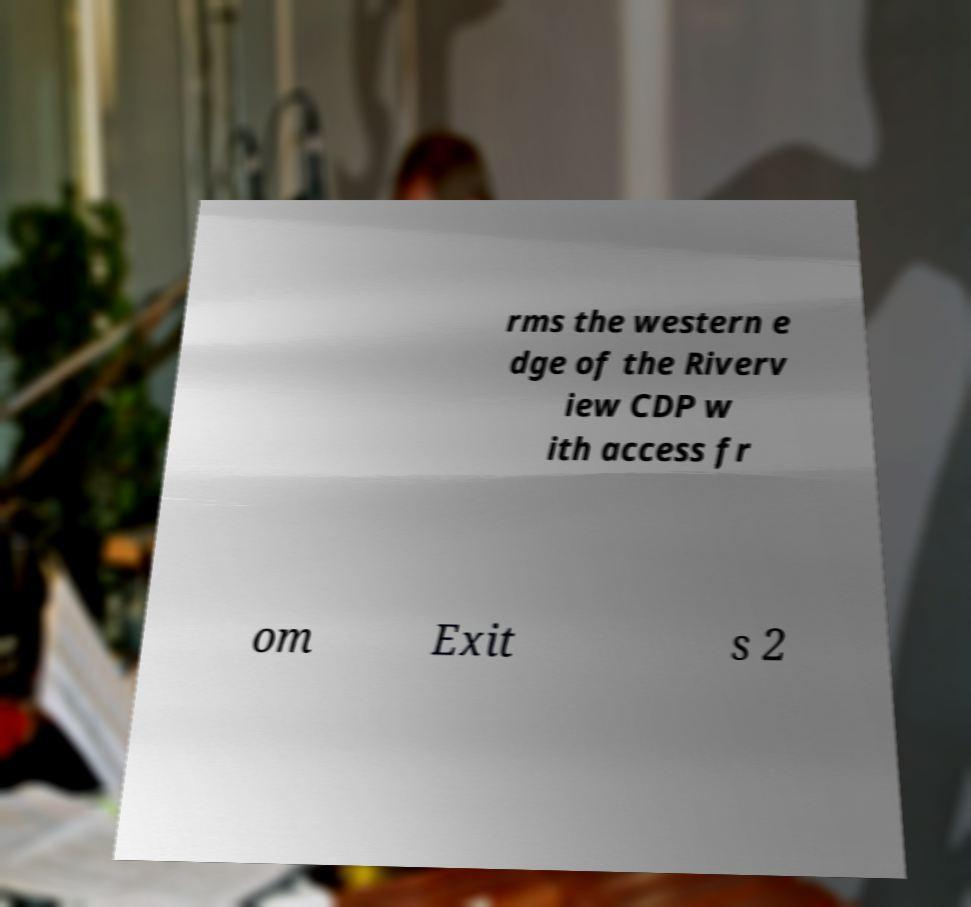Please identify and transcribe the text found in this image. rms the western e dge of the Riverv iew CDP w ith access fr om Exit s 2 